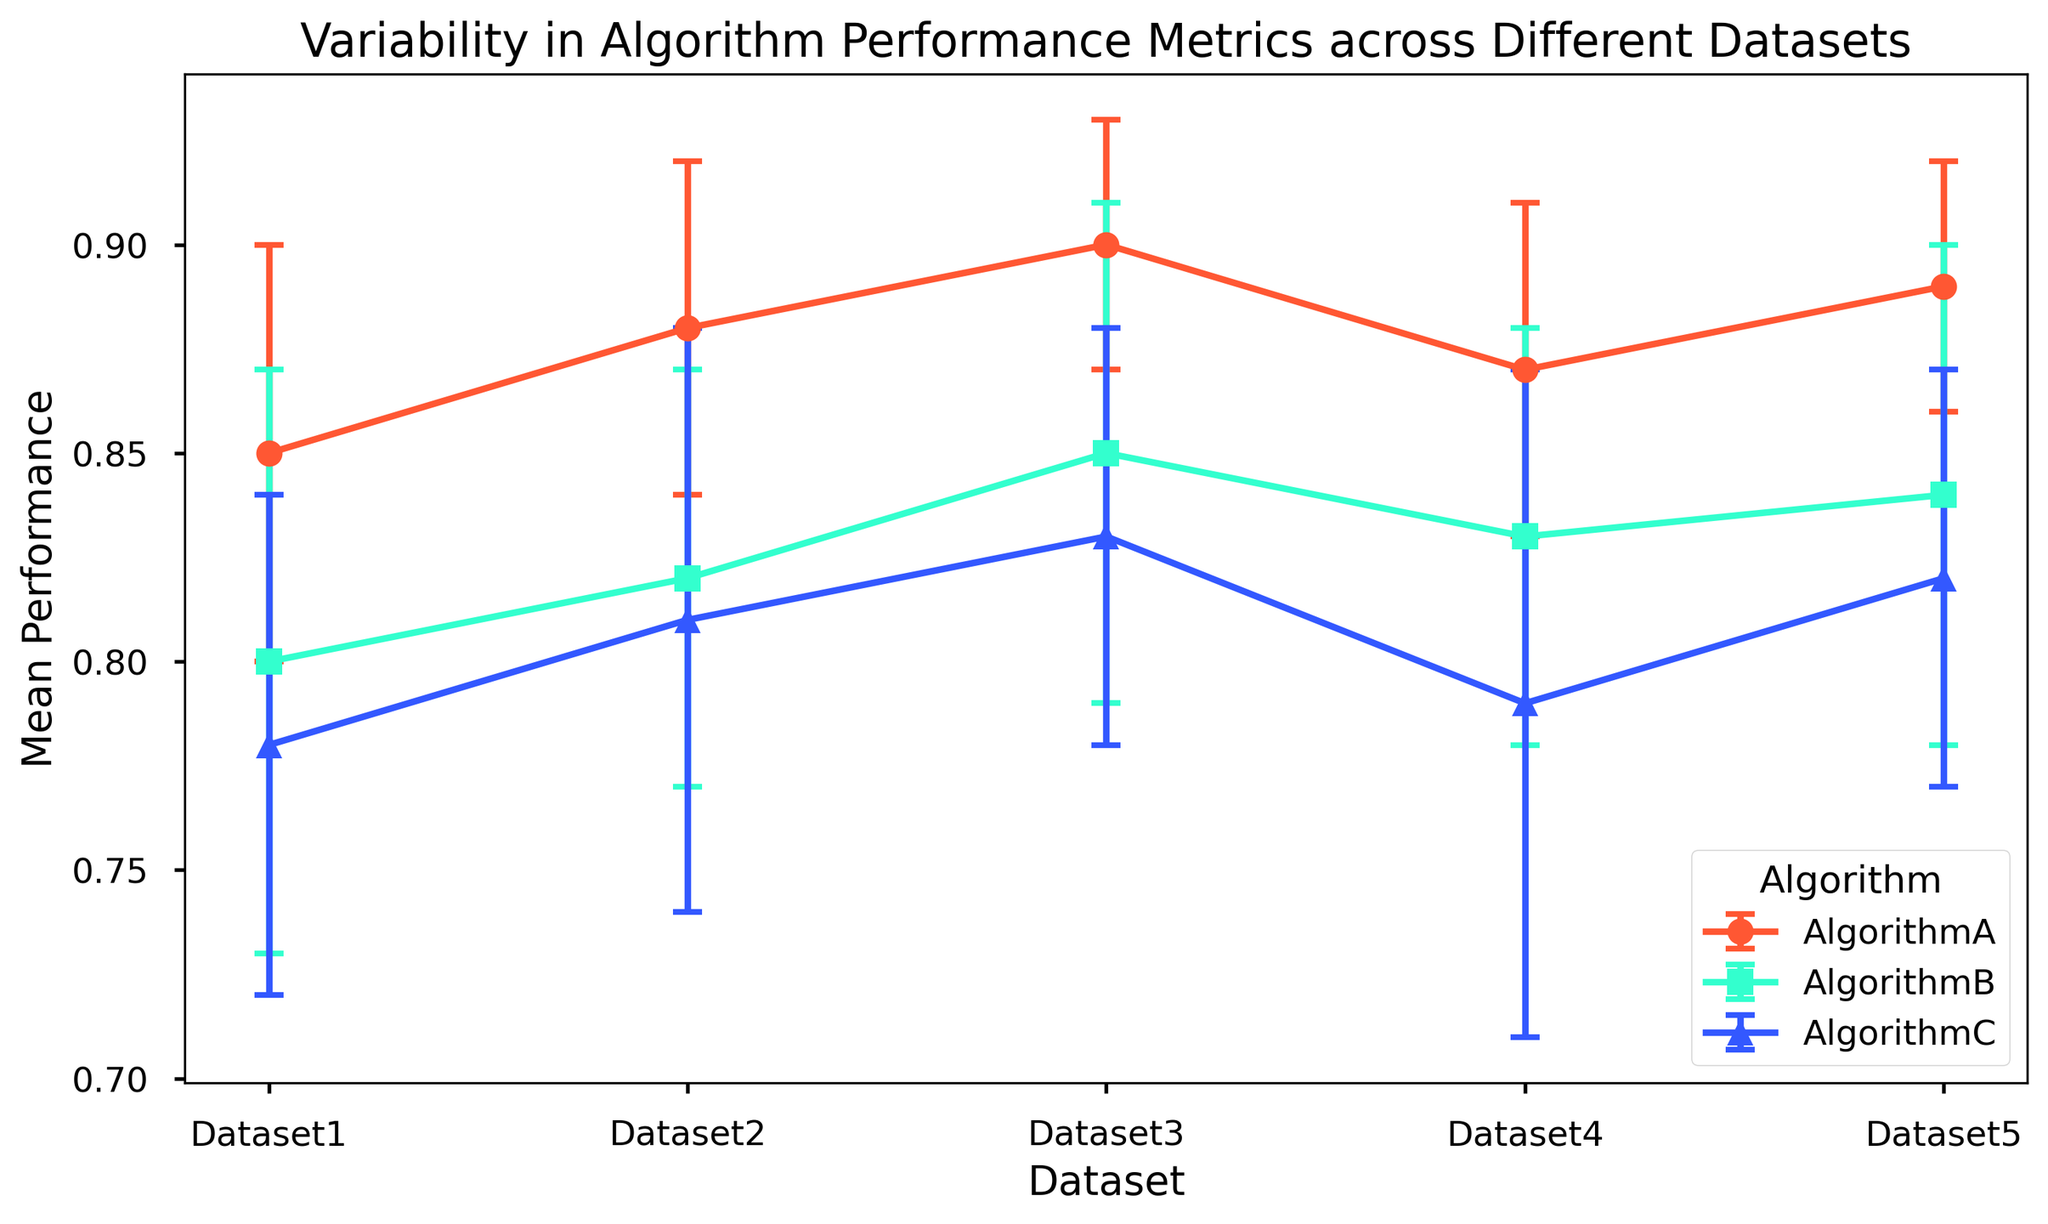What algorithm shows the highest mean performance across all datasets? Examine each dataset and compare the mean performance of AlgorithmA, AlgorithmB, and AlgorithmC. AlgorithmA consistently has the highest mean performance across all datasets.
Answer: AlgorithmA Which dataset has the highest variability in the performance of AlgorithmC? The standard deviation indicates variability. Check the standard deviation values for AlgorithmC across all datasets. The highest standard deviation for AlgorithmC is 0.08 on Dataset4.
Answer: Dataset4 Compare the performance of AlgorithmA and AlgorithmB on Dataset2. Which one performs better? Compare the mean performance values for AlgorithmA and AlgorithmB on Dataset2. AlgorithmA has a mean performance of 0.88, whereas AlgorithmB has 0.82.
Answer: AlgorithmA Which algorithm exhibits the most consistent performance across all datasets? Consistency can be indicated by the lowest overall standard deviation. Examine the standard deviations across all datasets for each algorithm. AlgorithmA has the lowest overall standard deviation values.
Answer: AlgorithmA On Dataset3, what’s the difference in mean performance between AlgorithmB and AlgorithmC? Subtract the mean performance of AlgorithmC from AlgorithmB on Dataset3 (0.85 - 0.83).
Answer: 0.02 Identify the dataset where AlgorithmB and AlgorithmC have the smallest difference in mean performance. Calculate the difference in mean performance between AlgorithmB and AlgorithmC for each dataset and look for the smallest value. The smallest difference is on Dataset2 (0.82 - 0.81 = 0.01).
Answer: Dataset2 What can be inferred from the error bars for AlgorithmA across different datasets? The error bars represent standard deviations. Compare the length of the error bars for AlgorithmA across the datasets. The smaller error bars indicate more consistent performance for AlgorithmA.
Answer: AlgorithmA shows consistent performance For Dataset1, calculate the average standard deviation of all algorithms. Add up the standard deviations for each algorithm on Dataset1 and divide by the number of algorithms. (0.05 + 0.07 + 0.06) / 3 = 0.06.
Answer: 0.06 Among Dataset5, which algorithm has the highest mean performance, and by how much? Compare the mean performance of AlgorithmA, AlgorithmB, and AlgorithmC on Dataset5. AlgorithmA has the highest mean performance at 0.89. Subtract the highest from others to find the difference (0.89 - 0.84 and 0.89 - 0.82).
Answer: AlgorithmA by 0.05 and 0.07 Overall, which dataset allows all algorithms to perform above 0.80 mean performance? Check the mean performance values for all algorithms in each dataset and identify which dataset has values above 0.80 for all. Dataset2 and Dataset5 both satisfy this condition.
Answer: Dataset2 and Dataset5 